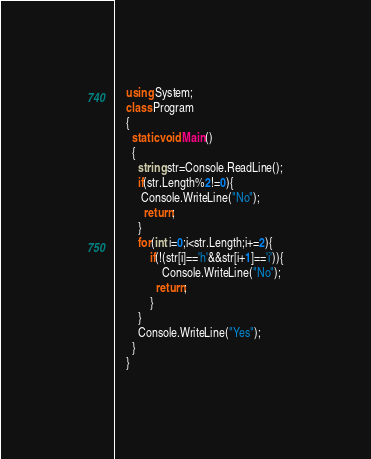<code> <loc_0><loc_0><loc_500><loc_500><_C#_>    using System;
    class Program
    {
      static void Main()
      {
      	string str=Console.ReadLine();
        if(str.Length%2!=0){
         Console.WriteLine("No");
          return;
        }
        for(int i=0;i<str.Length;i+=2){
        	if(!(str[i]=='h'&&str[i+1]=='i')){
            	Console.WriteLine("No");
              return;
            }
        }
        Console.WriteLine("Yes");
      }
    }</code> 